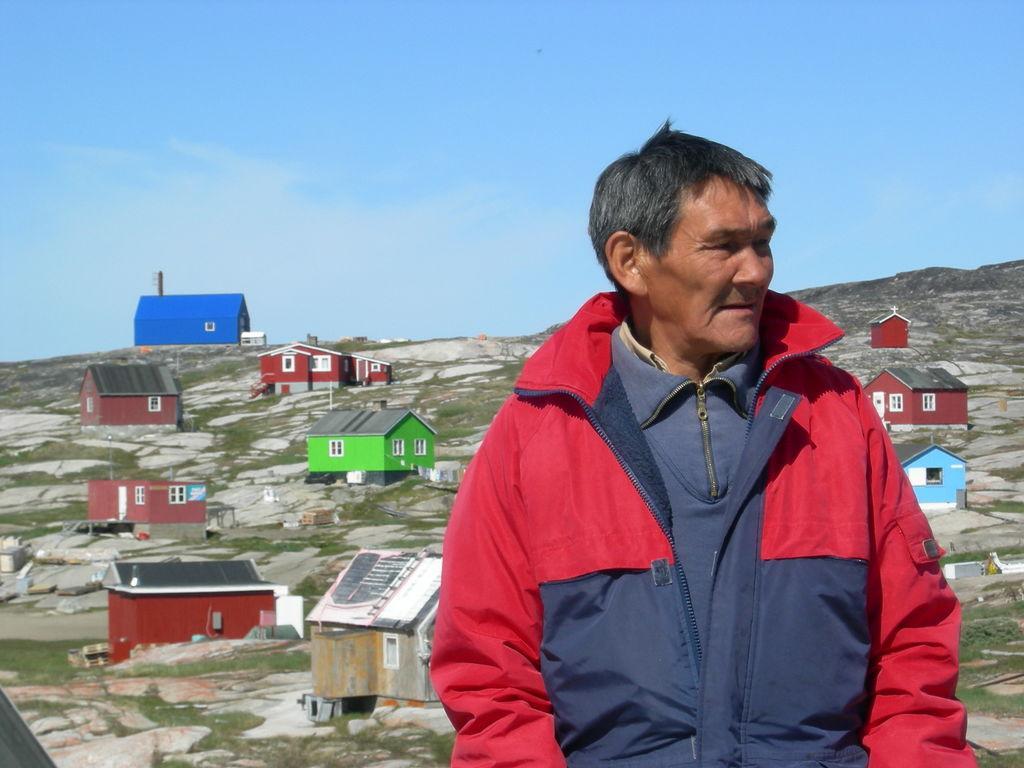Please provide a concise description of this image. In this picture we can see old men wearing a red and blue color jacket standing in the front of the images, Behind we can see small colorful houses on the hills and above we can see blue sky. 